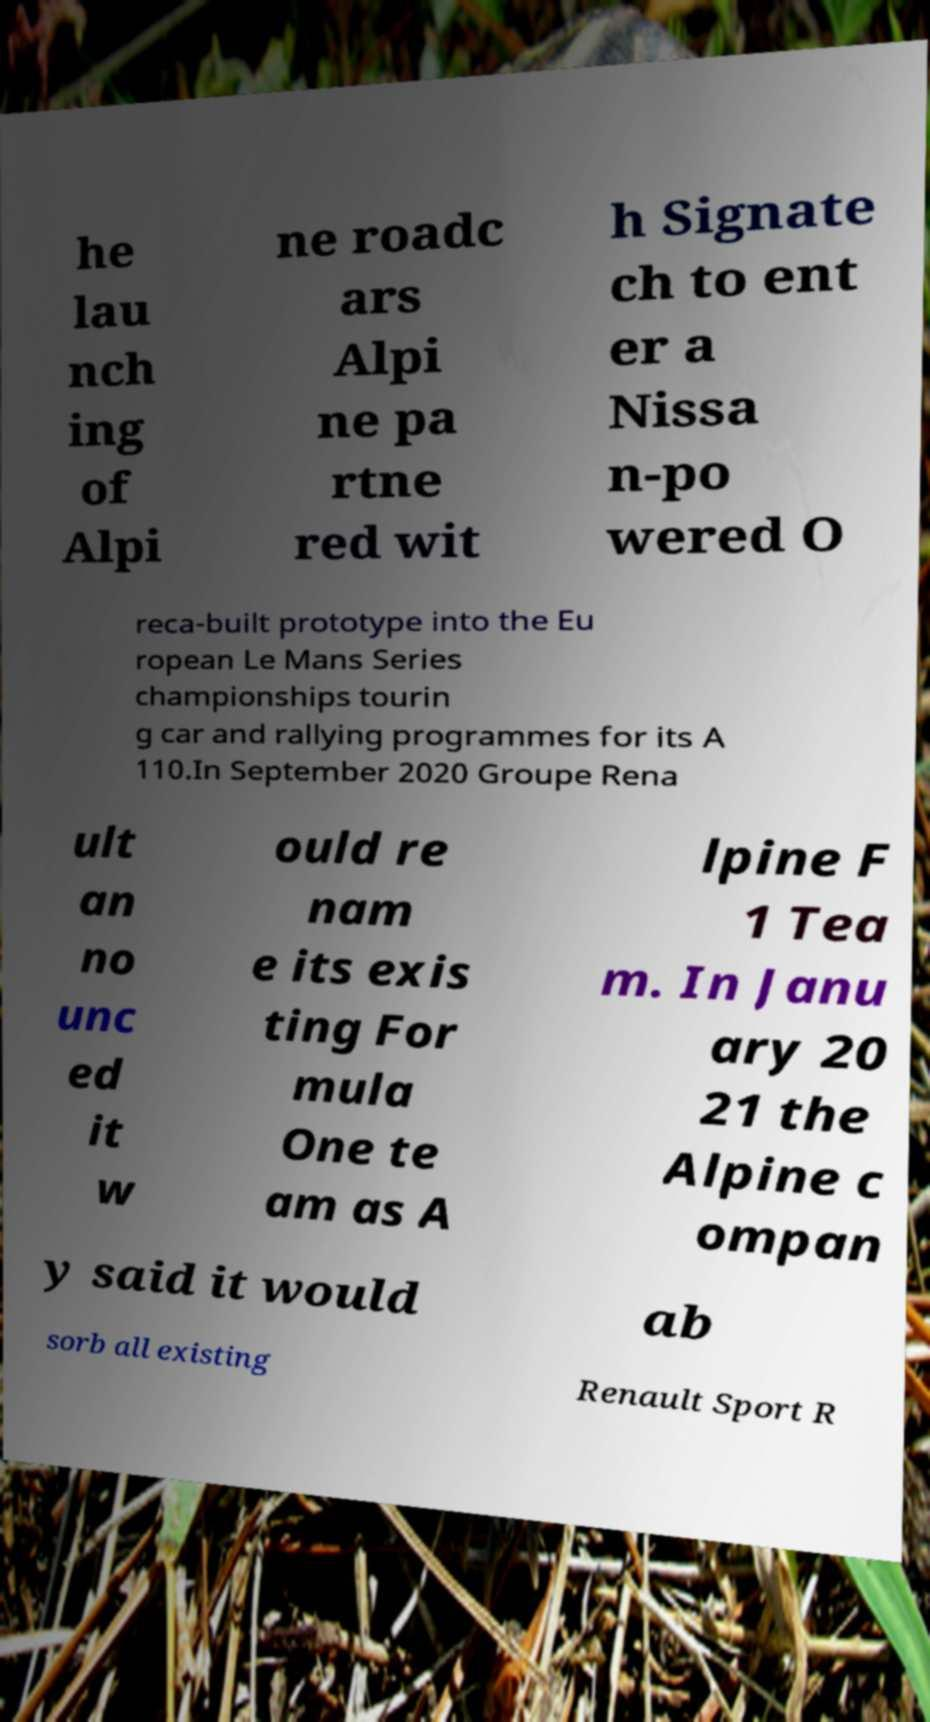I need the written content from this picture converted into text. Can you do that? he lau nch ing of Alpi ne roadc ars Alpi ne pa rtne red wit h Signate ch to ent er a Nissa n-po wered O reca-built prototype into the Eu ropean Le Mans Series championships tourin g car and rallying programmes for its A 110.In September 2020 Groupe Rena ult an no unc ed it w ould re nam e its exis ting For mula One te am as A lpine F 1 Tea m. In Janu ary 20 21 the Alpine c ompan y said it would ab sorb all existing Renault Sport R 